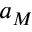Convert formula to latex. <formula><loc_0><loc_0><loc_500><loc_500>a _ { M }</formula> 